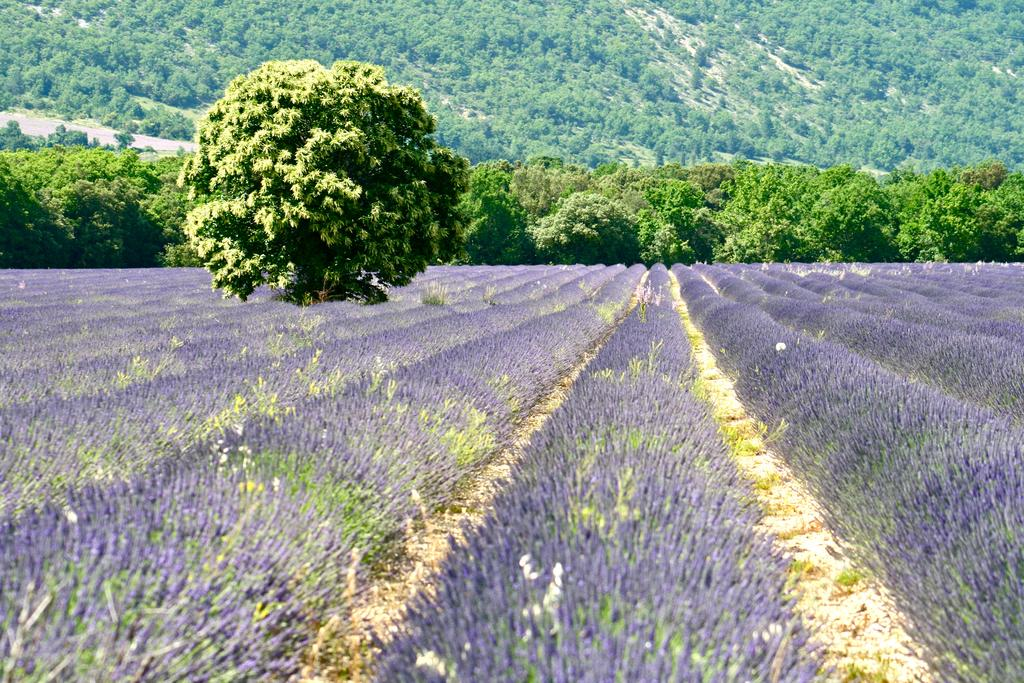What is located in the center of the image? There are trees and plants in the center of the image. Can you describe the trees and plants in the image? The trees and plants are the main focus in the center of the image. Can you see a bat hanging from the trees in the image? There is no bat present in the image; it only features trees and plants. How does the mountain contribute to the balance of the image? There is no mountain present in the image, so it cannot contribute to the balance. 